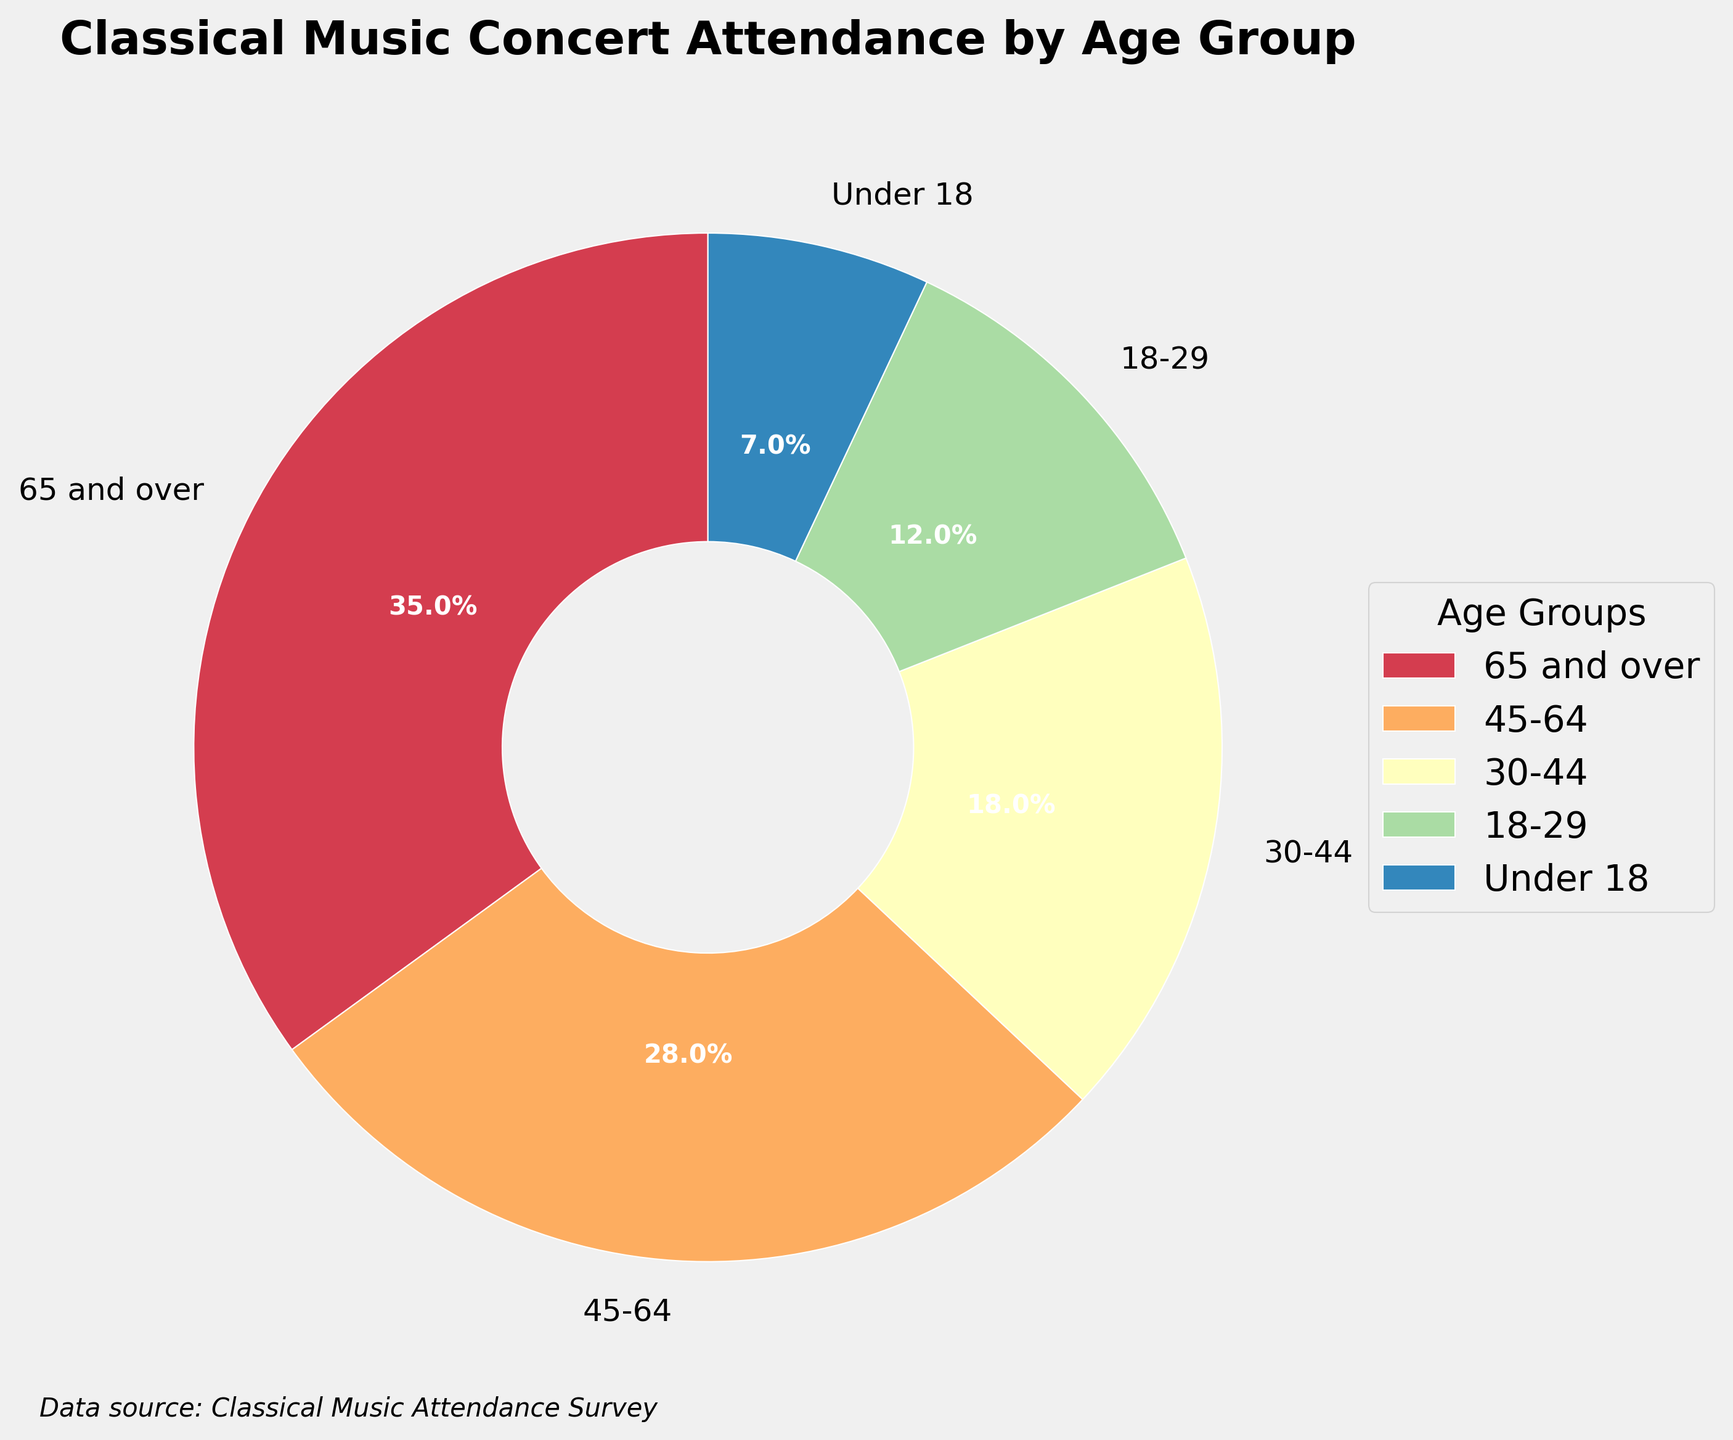Which age group has the highest percentage of classical music concert attendance? The pie chart shows a breakdown by age group, and the largest segment is for those aged 65 and over.
Answer: 65 and over What is the combined percentage of concert attendance for those under 18 and 18-29? The figure shows 7% for under 18 and 12% for 18-29. Adding these together gives 7% + 12% = 19%.
Answer: 19% Which two age groups together make up more than half of the concert attendance? The two largest segments are 65 and over (35%) and 45-64 (28%). Adding these gives 35% + 28% = 63%.
Answer: 65 and over, and 45-64 What is the difference in concert attendance percentage between the age groups 45-64 and 30-44? The chart shows 28% for 45-64 and 18% for 30-44. Subtracting these gives 28% - 18% = 10%.
Answer: 10% Which age group has the smallest percentage of concert attendance? The smallest segment in the pie chart is labeled under 18, with 7%.
Answer: Under 18 What percentage of concert attendees are aged 30-44 or younger? The relevant segments are 30-44 (18%), 18-29 (12%), and under 18 (7%). Adding these gives 18% + 12% + 7% = 37%.
Answer: 37% Compare the percentage of concert attendance for those aged 65 and over with those aged 18-29. The chart shows 35% for 65 and over and 12% for 18-29. 35% is higher than 12%.
Answer: 65 and over have a higher percentage How much more is the percentage of attendees aged 65 and over compared to those aged under 18? The figure shows 35% for 65 and over and 7% for under 18. Subtracting these gives 35% - 7% = 28%.
Answer: 28% What is the percentage of concert attendees aged 45 and over? The relevant segments are 65 and over (35%) and 45-64 (28%). Adding these gives 35% + 28% = 63%.
Answer: 63% What age group holds the third-largest segment of attendance? The third-largest segment in the pie chart is labeled 30-44 with 18%.
Answer: 30-44 